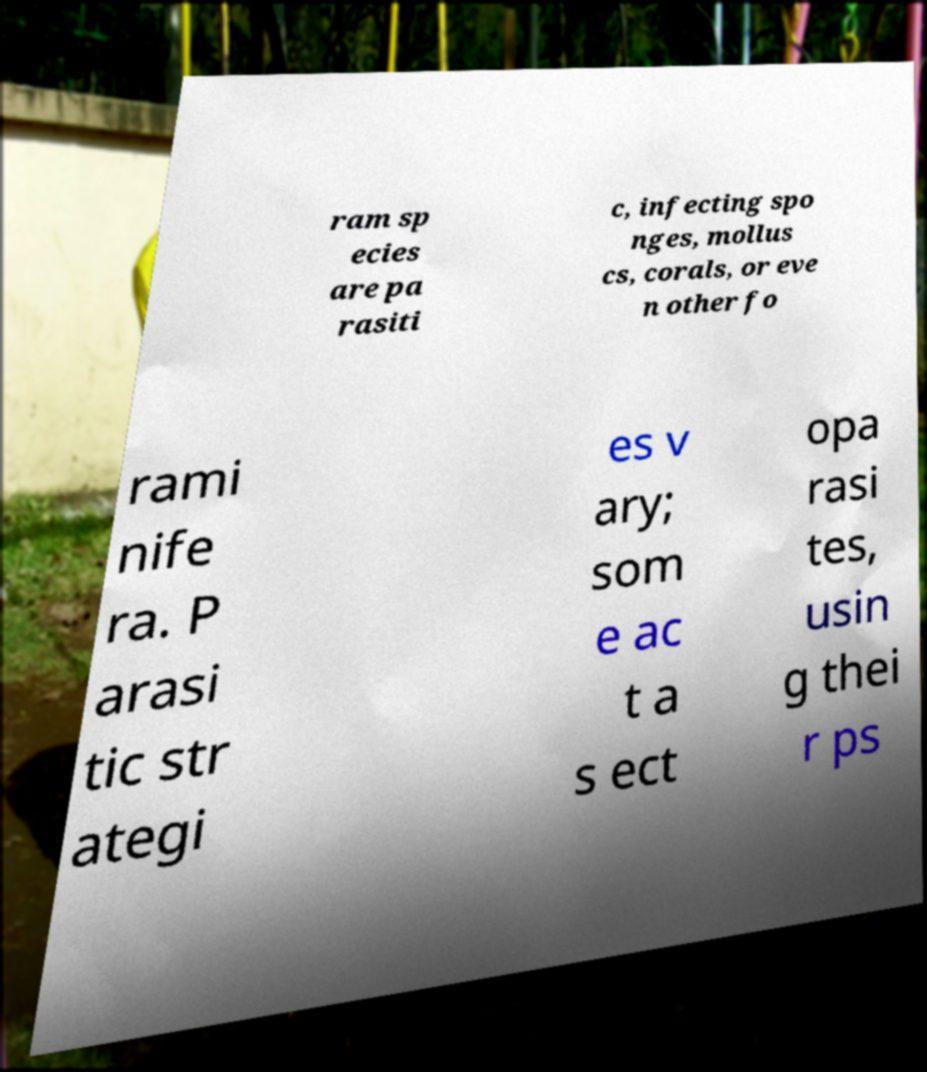Can you accurately transcribe the text from the provided image for me? ram sp ecies are pa rasiti c, infecting spo nges, mollus cs, corals, or eve n other fo rami nife ra. P arasi tic str ategi es v ary; som e ac t a s ect opa rasi tes, usin g thei r ps 